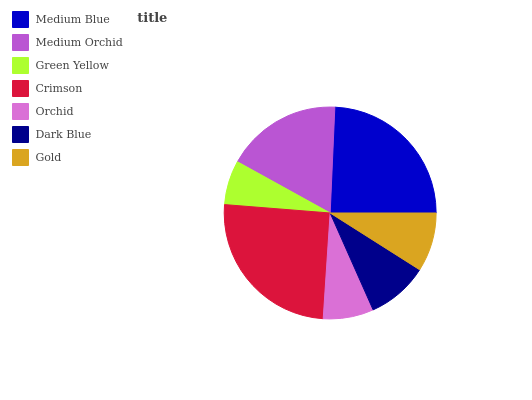Is Green Yellow the minimum?
Answer yes or no. Yes. Is Crimson the maximum?
Answer yes or no. Yes. Is Medium Orchid the minimum?
Answer yes or no. No. Is Medium Orchid the maximum?
Answer yes or no. No. Is Medium Blue greater than Medium Orchid?
Answer yes or no. Yes. Is Medium Orchid less than Medium Blue?
Answer yes or no. Yes. Is Medium Orchid greater than Medium Blue?
Answer yes or no. No. Is Medium Blue less than Medium Orchid?
Answer yes or no. No. Is Dark Blue the high median?
Answer yes or no. Yes. Is Dark Blue the low median?
Answer yes or no. Yes. Is Orchid the high median?
Answer yes or no. No. Is Medium Orchid the low median?
Answer yes or no. No. 